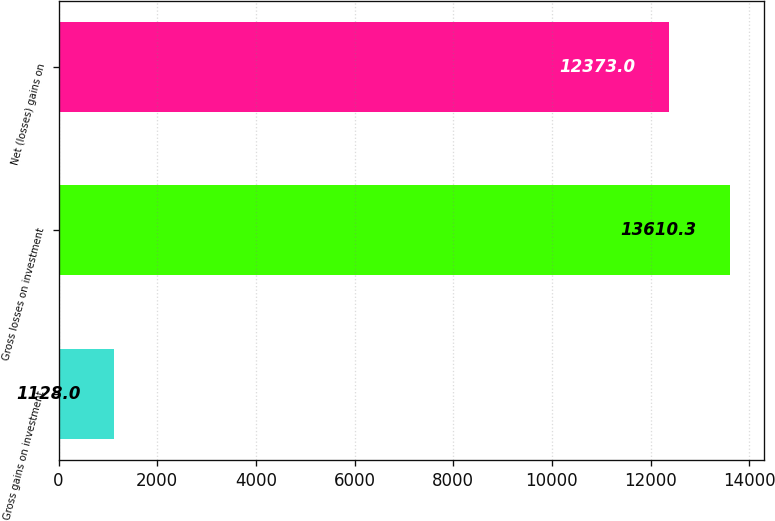Convert chart to OTSL. <chart><loc_0><loc_0><loc_500><loc_500><bar_chart><fcel>Gross gains on investment<fcel>Gross losses on investment<fcel>Net (losses) gains on<nl><fcel>1128<fcel>13610.3<fcel>12373<nl></chart> 